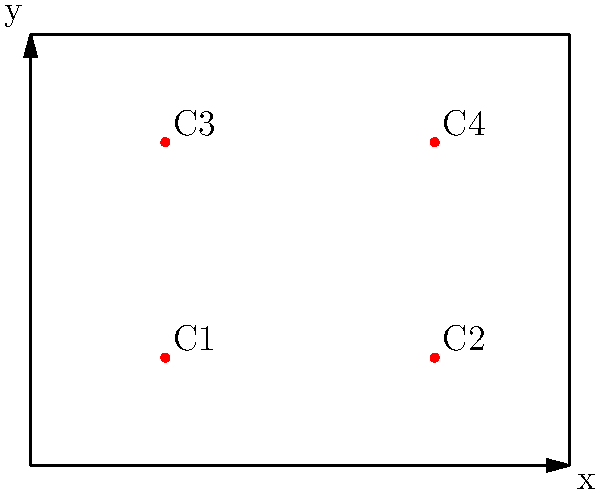In the reconstruction of a Roman temple, archaeologists need to determine the optimal placement of four support columns. Using linear algebra and optimization techniques, they have narrowed down the positions to the following coordinates (in meters):

C1(25, 20), C2(75, 20), C3(25, 60), C4(75, 60)

If the temple's floor plan is represented by a 100m x 80m rectangle, what is the total distance between all pairs of columns, rounded to the nearest meter? To solve this problem, we'll follow these steps:

1) First, we need to calculate the distance between each pair of columns using the distance formula:
   $d = \sqrt{(x_2-x_1)^2 + (y_2-y_1)^2}$

2) There are 6 pairs of columns to consider:
   C1-C2, C1-C3, C1-C4, C2-C3, C2-C4, C3-C4

3) Let's calculate each distance:

   C1-C2: $d_{12} = \sqrt{(75-25)^2 + (20-20)^2} = 50$
   C1-C3: $d_{13} = \sqrt{(25-25)^2 + (60-20)^2} = 40$
   C1-C4: $d_{14} = \sqrt{(75-25)^2 + (60-20)^2} = \sqrt{2500 + 1600} = \sqrt{4100} \approx 64.03$
   C2-C3: $d_{23} = \sqrt{(25-75)^2 + (60-20)^2} = \sqrt{2500 + 1600} = \sqrt{4100} \approx 64.03$
   C2-C4: $d_{24} = \sqrt{(75-75)^2 + (60-20)^2} = 40$
   C3-C4: $d_{34} = \sqrt{(75-25)^2 + (60-60)^2} = 50$

4) Now, we sum all these distances:
   Total distance = 50 + 40 + 64.03 + 64.03 + 40 + 50 = 308.06 meters

5) Rounding to the nearest meter:
   308.06 ≈ 308 meters

Therefore, the total distance between all pairs of columns, rounded to the nearest meter, is 308 meters.
Answer: 308 meters 